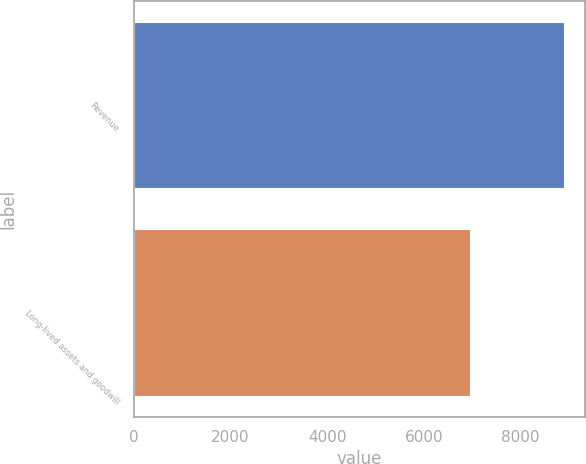Convert chart. <chart><loc_0><loc_0><loc_500><loc_500><bar_chart><fcel>Revenue<fcel>Long-lived assets and goodwill<nl><fcel>8900<fcel>6946.1<nl></chart> 